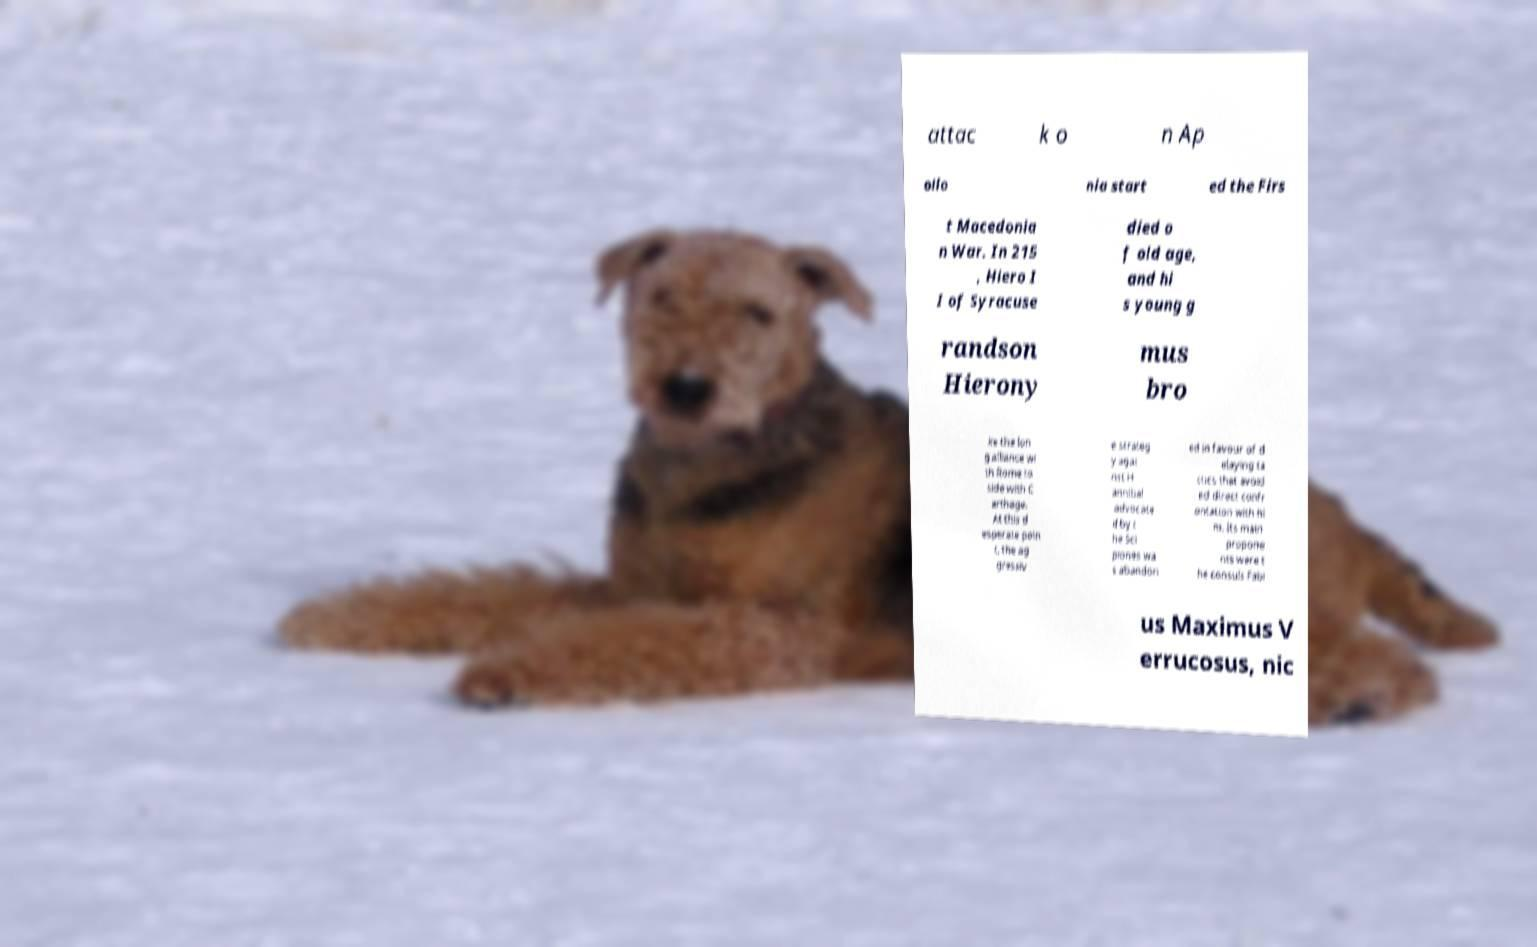Could you assist in decoding the text presented in this image and type it out clearly? attac k o n Ap ollo nia start ed the Firs t Macedonia n War. In 215 , Hiero I I of Syracuse died o f old age, and hi s young g randson Hierony mus bro ke the lon g alliance wi th Rome to side with C arthage. At this d esperate poin t, the ag gressiv e strateg y agai nst H annibal advocate d by t he Sci piones wa s abandon ed in favour of d elaying ta ctics that avoid ed direct confr ontation with hi m. Its main propone nts were t he consuls Fabi us Maximus V errucosus, nic 